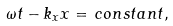<formula> <loc_0><loc_0><loc_500><loc_500>\omega t - k _ { x } x = \, c o n s t a n t ,</formula> 